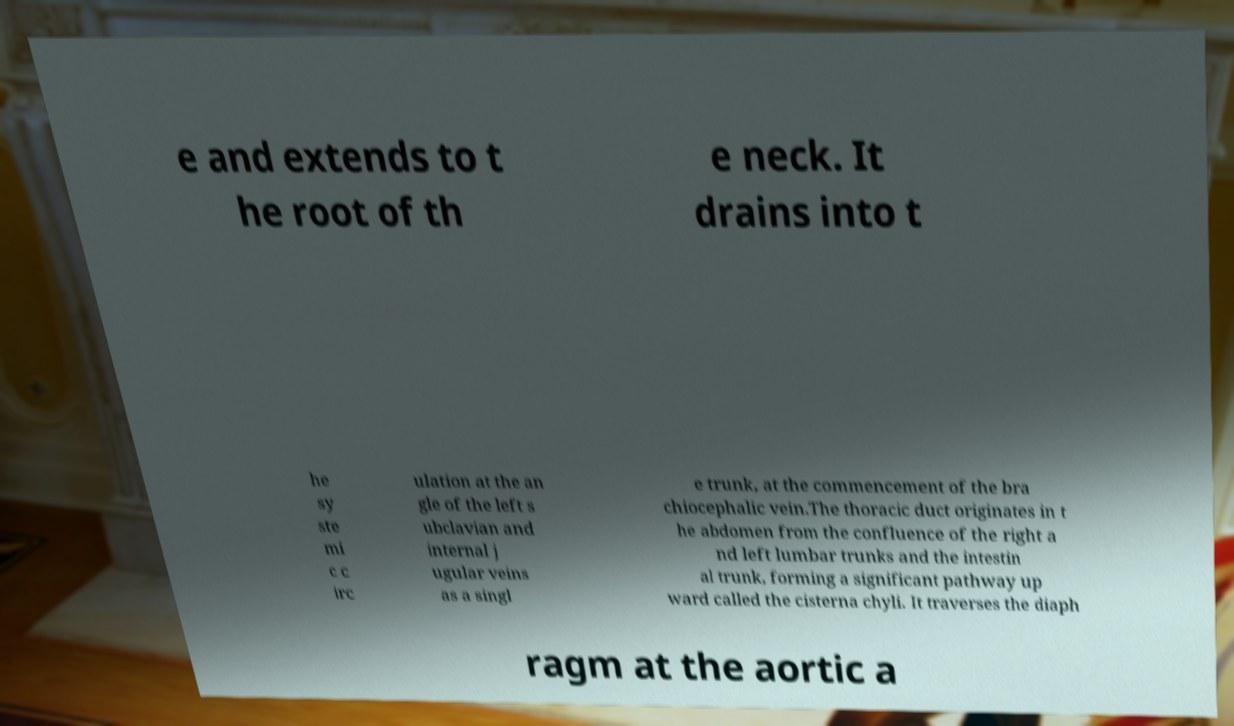For documentation purposes, I need the text within this image transcribed. Could you provide that? e and extends to t he root of th e neck. It drains into t he sy ste mi c c irc ulation at the an gle of the left s ubclavian and internal j ugular veins as a singl e trunk, at the commencement of the bra chiocephalic vein.The thoracic duct originates in t he abdomen from the confluence of the right a nd left lumbar trunks and the intestin al trunk, forming a significant pathway up ward called the cisterna chyli. It traverses the diaph ragm at the aortic a 